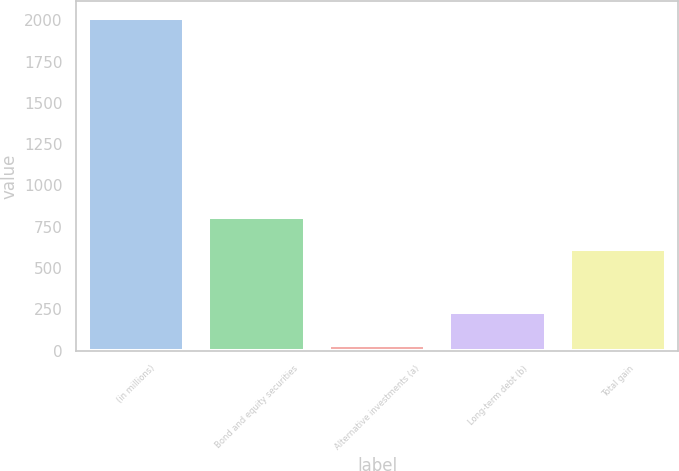<chart> <loc_0><loc_0><loc_500><loc_500><bar_chart><fcel>(in millions)<fcel>Bond and equity securities<fcel>Alternative investments (a)<fcel>Long-term debt (b)<fcel>Total gain<nl><fcel>2015<fcel>810.9<fcel>36<fcel>233.9<fcel>613<nl></chart> 